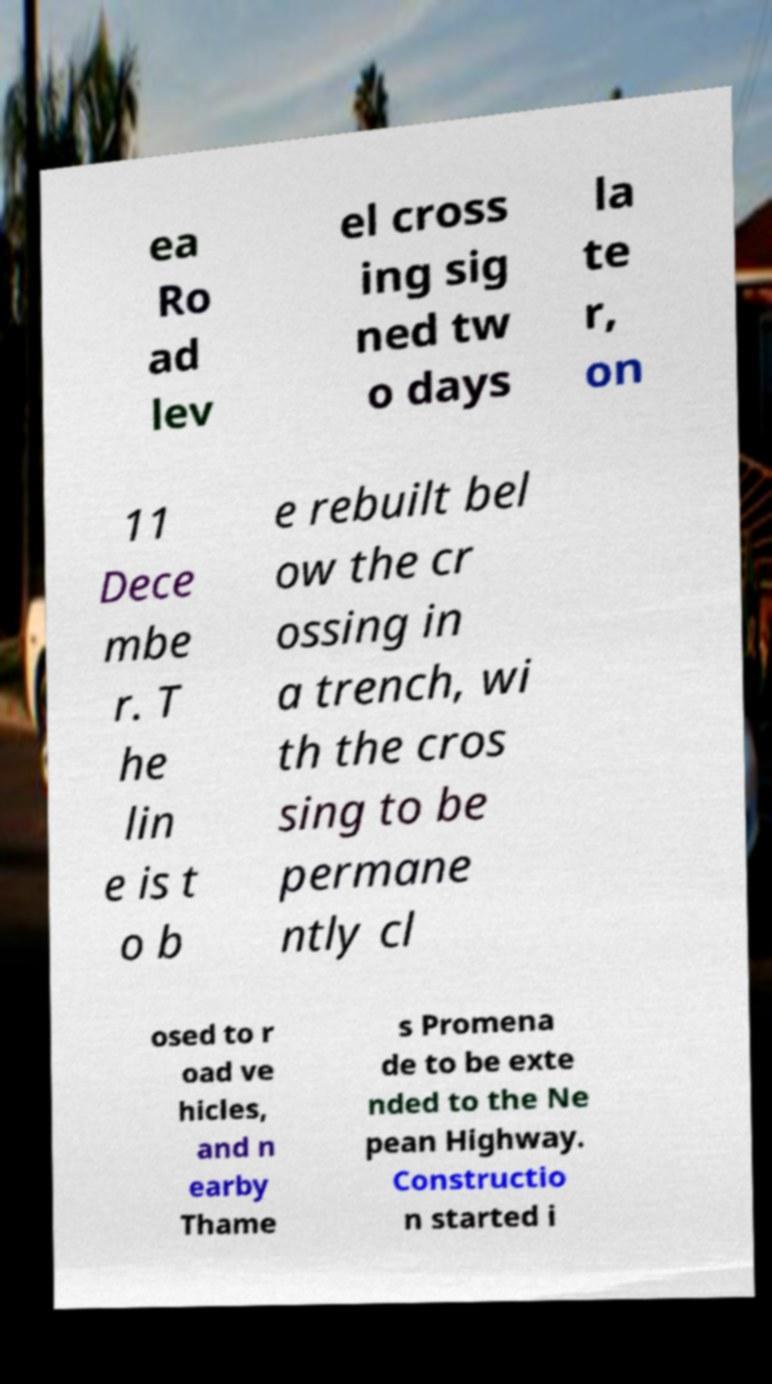Please read and relay the text visible in this image. What does it say? ea Ro ad lev el cross ing sig ned tw o days la te r, on 11 Dece mbe r. T he lin e is t o b e rebuilt bel ow the cr ossing in a trench, wi th the cros sing to be permane ntly cl osed to r oad ve hicles, and n earby Thame s Promena de to be exte nded to the Ne pean Highway. Constructio n started i 